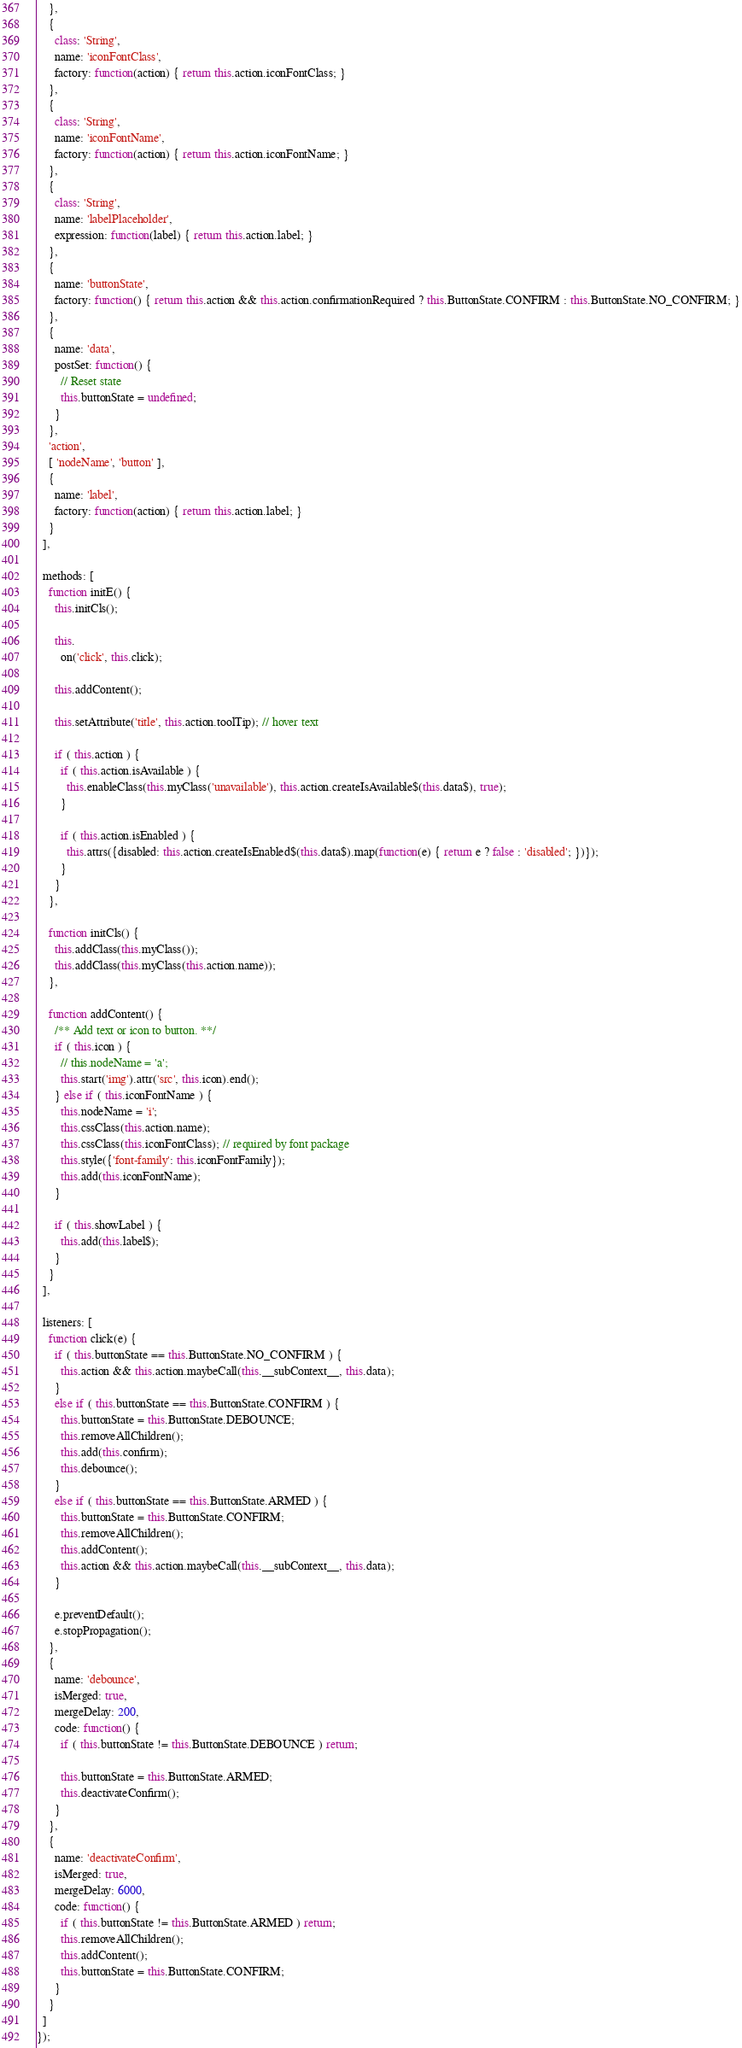<code> <loc_0><loc_0><loc_500><loc_500><_JavaScript_>    },
    {
      class: 'String',
      name: 'iconFontClass',
      factory: function(action) { return this.action.iconFontClass; }
    },
    {
      class: 'String',
      name: 'iconFontName',
      factory: function(action) { return this.action.iconFontName; }
    },
    {
      class: 'String',
      name: 'labelPlaceholder',
      expression: function(label) { return this.action.label; }
    },
    {
      name: 'buttonState',
      factory: function() { return this.action && this.action.confirmationRequired ? this.ButtonState.CONFIRM : this.ButtonState.NO_CONFIRM; }
    },
    {
      name: 'data',
      postSet: function() {
        // Reset state
        this.buttonState = undefined;
      }
    },
    'action',
    [ 'nodeName', 'button' ],
    {
      name: 'label',
      factory: function(action) { return this.action.label; }
    }
  ],

  methods: [
    function initE() {
      this.initCls();

      this.
        on('click', this.click);

      this.addContent();

      this.setAttribute('title', this.action.toolTip); // hover text

      if ( this.action ) {
        if ( this.action.isAvailable ) {
          this.enableClass(this.myClass('unavailable'), this.action.createIsAvailable$(this.data$), true);
        }

        if ( this.action.isEnabled ) {
          this.attrs({disabled: this.action.createIsEnabled$(this.data$).map(function(e) { return e ? false : 'disabled'; })});
        }
      }
    },

    function initCls() {
      this.addClass(this.myClass());
      this.addClass(this.myClass(this.action.name));
    },

    function addContent() {
      /** Add text or icon to button. **/
      if ( this.icon ) {
        // this.nodeName = 'a';
        this.start('img').attr('src', this.icon).end();
      } else if ( this.iconFontName ) {
        this.nodeName = 'i';
        this.cssClass(this.action.name);
        this.cssClass(this.iconFontClass); // required by font package
        this.style({'font-family': this.iconFontFamily});
        this.add(this.iconFontName);
      }

      if ( this.showLabel ) {
        this.add(this.label$);
      }
    }
  ],

  listeners: [
    function click(e) {
      if ( this.buttonState == this.ButtonState.NO_CONFIRM ) {
        this.action && this.action.maybeCall(this.__subContext__, this.data);
      }
      else if ( this.buttonState == this.ButtonState.CONFIRM ) {
        this.buttonState = this.ButtonState.DEBOUNCE;
        this.removeAllChildren();
        this.add(this.confirm);
        this.debounce();
      }
      else if ( this.buttonState == this.ButtonState.ARMED ) {
        this.buttonState = this.ButtonState.CONFIRM;
        this.removeAllChildren();
        this.addContent();
        this.action && this.action.maybeCall(this.__subContext__, this.data);
      }
      
      e.preventDefault();
      e.stopPropagation();
    },
    {
      name: 'debounce',
      isMerged: true,
      mergeDelay: 200,
      code: function() {
        if ( this.buttonState != this.ButtonState.DEBOUNCE ) return;

        this.buttonState = this.ButtonState.ARMED;
        this.deactivateConfirm();
      }
    },
    {
      name: 'deactivateConfirm',
      isMerged: true,
      mergeDelay: 6000,
      code: function() {
        if ( this.buttonState != this.ButtonState.ARMED ) return;
        this.removeAllChildren();
        this.addContent();
        this.buttonState = this.ButtonState.CONFIRM;
      }
    }
  ]
});
</code> 